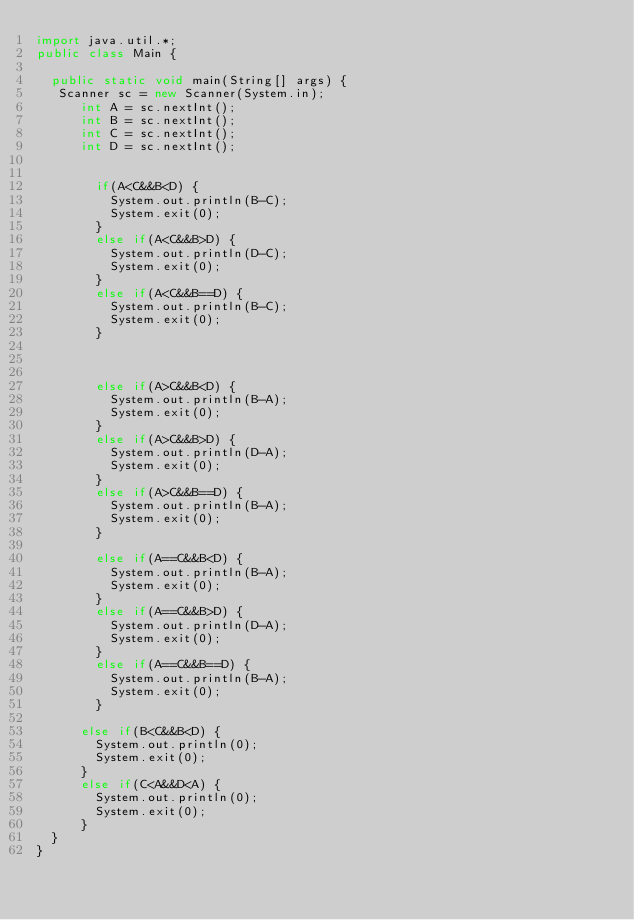Convert code to text. <code><loc_0><loc_0><loc_500><loc_500><_Java_>import java.util.*;
public class Main {

	public static void main(String[] args) {
	 Scanner sc = new Scanner(System.in);
      int A = sc.nextInt();
      int B = sc.nextInt();
      int C = sc.nextInt();
      int D = sc.nextInt();
      
  
    	  if(A<C&&B<D) {
    		  System.out.println(B-C);
    		  System.exit(0);
    	  }
    	  else if(A<C&&B>D) {
    		  System.out.println(D-C);
    		  System.exit(0);
    	  }
    	  else if(A<C&&B==D) {
    		  System.out.println(B-C);
    		  System.exit(0);
    	  }
      
      
    
    	  else if(A>C&&B<D) {
    		  System.out.println(B-A);
    		  System.exit(0);
    	  }
    	  else if(A>C&&B>D) {
    		  System.out.println(D-A);
    		  System.exit(0);
    	  }
    	  else if(A>C&&B==D) {
    		  System.out.println(B-A);
    		  System.exit(0);
    	  }
      
    	  else if(A==C&&B<D) {
    		  System.out.println(B-A);
    		  System.exit(0);
    	  }
    	  else if(A==C&&B>D) {
    		  System.out.println(D-A);
    		  System.exit(0);
    	  }
    	  else if(A==C&&B==D) {
    		  System.out.println(B-A);
    		  System.exit(0);
    	  }  
      
      else if(B<C&&B<D) {
    	  System.out.println(0);
    	  System.exit(0);
      }
      else if(C<A&&D<A) {
    	  System.out.println(0);
    	  System.exit(0);
      }
	}
}
</code> 